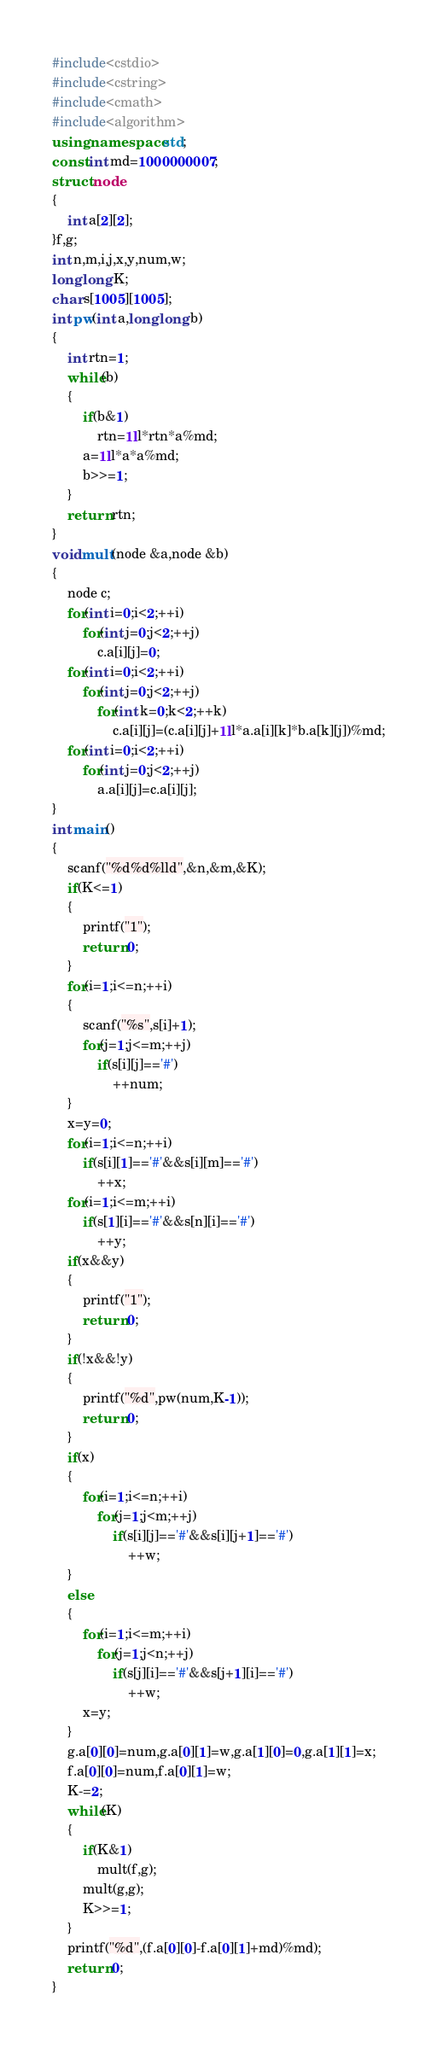<code> <loc_0><loc_0><loc_500><loc_500><_C++_>#include<cstdio>
#include<cstring>
#include<cmath>
#include<algorithm>
using namespace std;
const int md=1000000007;
struct node
{
	int a[2][2];
}f,g;
int n,m,i,j,x,y,num,w;
long long K;
char s[1005][1005];
int pw(int a,long long b)
{
	int rtn=1;
	while(b)
	{
		if(b&1)
			rtn=1ll*rtn*a%md;
		a=1ll*a*a%md;
		b>>=1;
	}
	return rtn;
}
void mult(node &a,node &b)
{
	node c;
	for(int i=0;i<2;++i)
		for(int j=0;j<2;++j)
			c.a[i][j]=0;
	for(int i=0;i<2;++i)
		for(int j=0;j<2;++j)
			for(int k=0;k<2;++k)
				c.a[i][j]=(c.a[i][j]+1ll*a.a[i][k]*b.a[k][j])%md;
	for(int i=0;i<2;++i)
		for(int j=0;j<2;++j)
			a.a[i][j]=c.a[i][j];
}
int main()
{
	scanf("%d%d%lld",&n,&m,&K);
	if(K<=1)
	{
		printf("1");
		return 0;
	}
	for(i=1;i<=n;++i)
	{
		scanf("%s",s[i]+1);
		for(j=1;j<=m;++j)
			if(s[i][j]=='#')
				++num;
	}
	x=y=0;
	for(i=1;i<=n;++i)
		if(s[i][1]=='#'&&s[i][m]=='#')
			++x;
	for(i=1;i<=m;++i)
		if(s[1][i]=='#'&&s[n][i]=='#')
			++y;
	if(x&&y)
	{
		printf("1");
		return 0;
	}
	if(!x&&!y)
	{
		printf("%d",pw(num,K-1));
		return 0;
	}
	if(x)
	{
		for(i=1;i<=n;++i)
			for(j=1;j<m;++j)
				if(s[i][j]=='#'&&s[i][j+1]=='#')
					++w;
	}
	else
	{
		for(i=1;i<=m;++i)
			for(j=1;j<n;++j)
				if(s[j][i]=='#'&&s[j+1][i]=='#')
					++w;
		x=y;
	}
	g.a[0][0]=num,g.a[0][1]=w,g.a[1][0]=0,g.a[1][1]=x;
	f.a[0][0]=num,f.a[0][1]=w;
	K-=2;
	while(K)
	{
		if(K&1)
			mult(f,g);
		mult(g,g);
		K>>=1;
	}
	printf("%d",(f.a[0][0]-f.a[0][1]+md)%md);
	return 0;
}</code> 